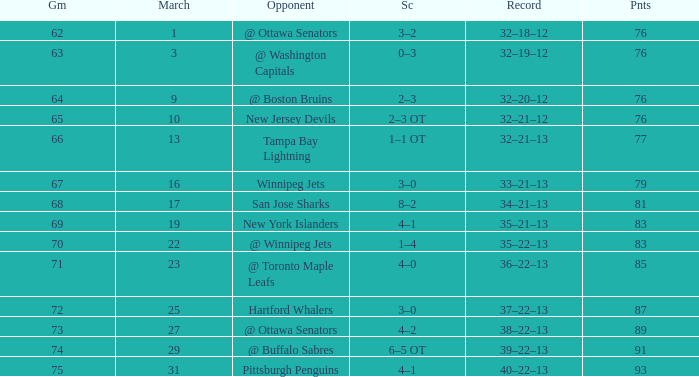How much March has Points of 85? 1.0. 